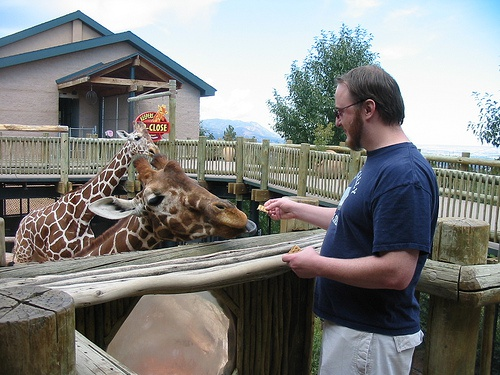Describe the objects in this image and their specific colors. I can see people in lightblue, black, navy, darkgray, and gray tones, giraffe in lightblue, black, gray, and maroon tones, and giraffe in lightblue, maroon, gray, darkgray, and lightgray tones in this image. 